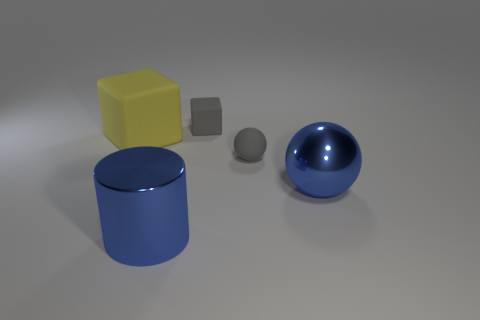Add 1 big shiny spheres. How many objects exist? 6 Subtract all balls. How many objects are left? 3 Add 2 blue metal things. How many blue metal things are left? 4 Add 2 big yellow blocks. How many big yellow blocks exist? 3 Subtract 0 green cubes. How many objects are left? 5 Subtract all blocks. Subtract all small gray blocks. How many objects are left? 2 